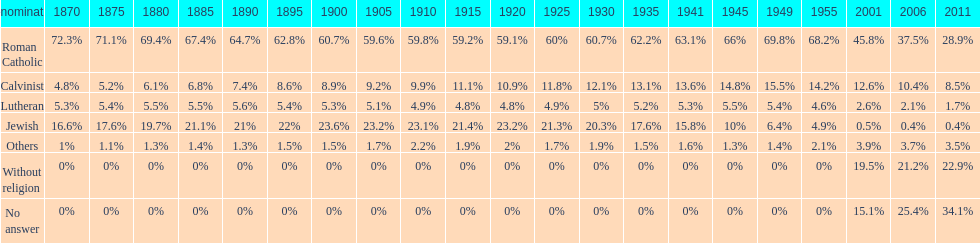The percentage of people who identified as calvinist was, at most, how much? 15.5%. 